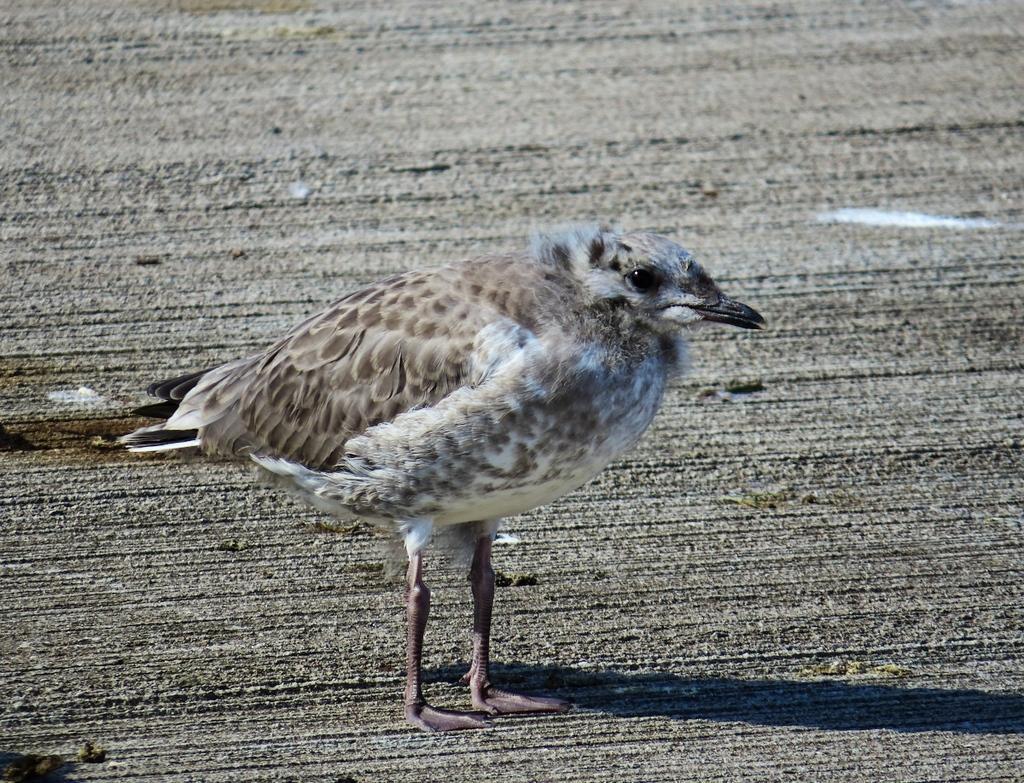Could you give a brief overview of what you see in this image? It is a bird standing, it is in brown color. 